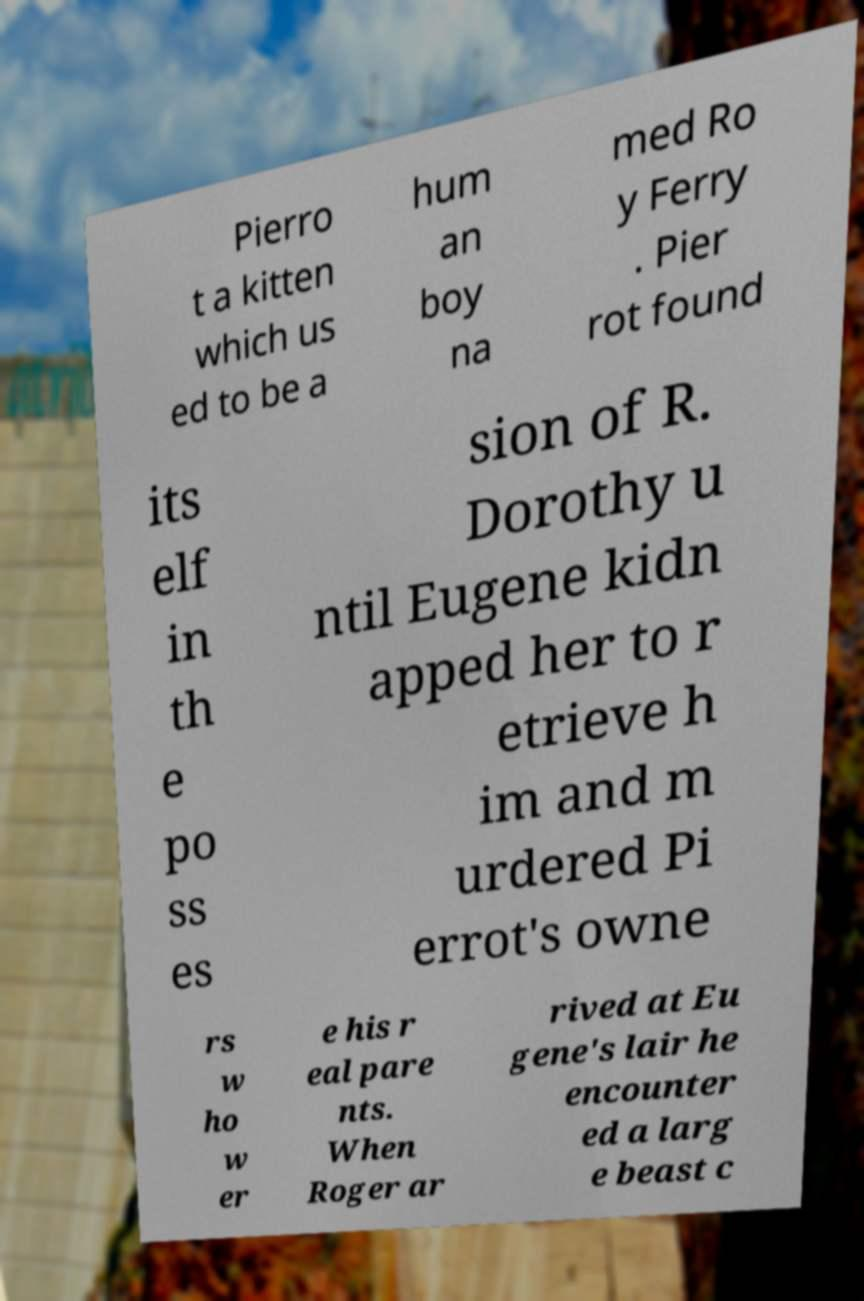I need the written content from this picture converted into text. Can you do that? Pierro t a kitten which us ed to be a hum an boy na med Ro y Ferry . Pier rot found its elf in th e po ss es sion of R. Dorothy u ntil Eugene kidn apped her to r etrieve h im and m urdered Pi errot's owne rs w ho w er e his r eal pare nts. When Roger ar rived at Eu gene's lair he encounter ed a larg e beast c 